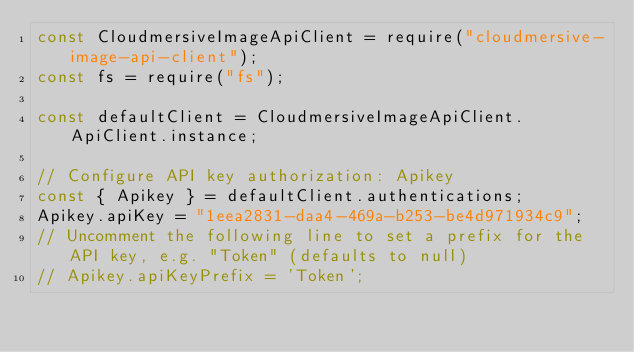<code> <loc_0><loc_0><loc_500><loc_500><_JavaScript_>const CloudmersiveImageApiClient = require("cloudmersive-image-api-client");
const fs = require("fs");

const defaultClient = CloudmersiveImageApiClient.ApiClient.instance;

// Configure API key authorization: Apikey
const { Apikey } = defaultClient.authentications;
Apikey.apiKey = "1eea2831-daa4-469a-b253-be4d971934c9";
// Uncomment the following line to set a prefix for the API key, e.g. "Token" (defaults to null)
// Apikey.apiKeyPrefix = 'Token';
</code> 